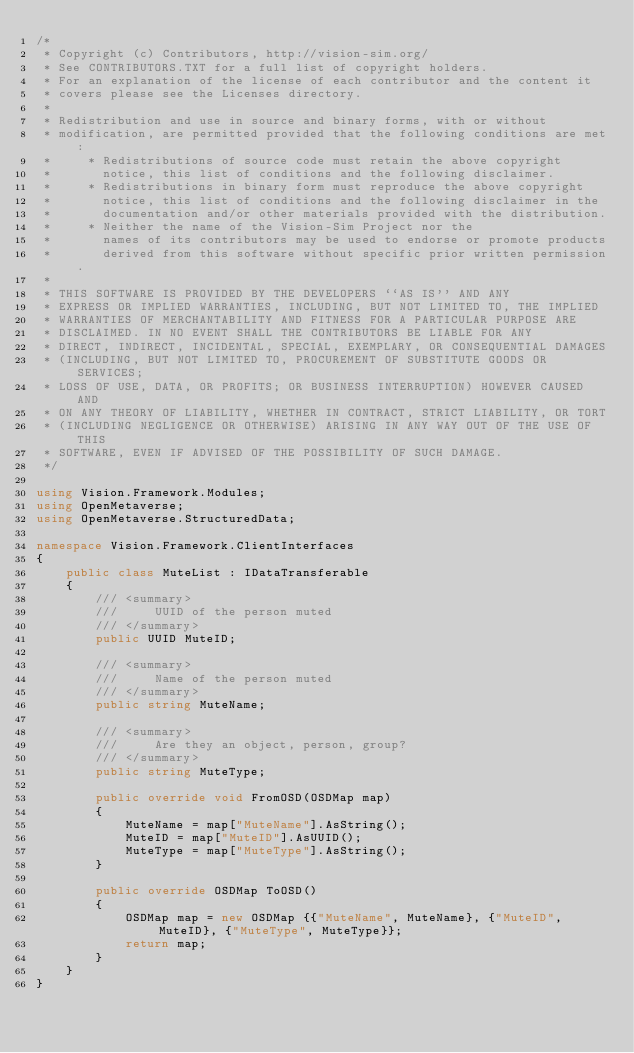Convert code to text. <code><loc_0><loc_0><loc_500><loc_500><_C#_>/*
 * Copyright (c) Contributors, http://vision-sim.org/
 * See CONTRIBUTORS.TXT for a full list of copyright holders.
 * For an explanation of the license of each contributor and the content it 
 * covers please see the Licenses directory.
 *
 * Redistribution and use in source and binary forms, with or without
 * modification, are permitted provided that the following conditions are met:
 *     * Redistributions of source code must retain the above copyright
 *       notice, this list of conditions and the following disclaimer.
 *     * Redistributions in binary form must reproduce the above copyright
 *       notice, this list of conditions and the following disclaimer in the
 *       documentation and/or other materials provided with the distribution.
 *     * Neither the name of the Vision-Sim Project nor the
 *       names of its contributors may be used to endorse or promote products
 *       derived from this software without specific prior written permission.
 *
 * THIS SOFTWARE IS PROVIDED BY THE DEVELOPERS ``AS IS'' AND ANY
 * EXPRESS OR IMPLIED WARRANTIES, INCLUDING, BUT NOT LIMITED TO, THE IMPLIED
 * WARRANTIES OF MERCHANTABILITY AND FITNESS FOR A PARTICULAR PURPOSE ARE
 * DISCLAIMED. IN NO EVENT SHALL THE CONTRIBUTORS BE LIABLE FOR ANY
 * DIRECT, INDIRECT, INCIDENTAL, SPECIAL, EXEMPLARY, OR CONSEQUENTIAL DAMAGES
 * (INCLUDING, BUT NOT LIMITED TO, PROCUREMENT OF SUBSTITUTE GOODS OR SERVICES;
 * LOSS OF USE, DATA, OR PROFITS; OR BUSINESS INTERRUPTION) HOWEVER CAUSED AND
 * ON ANY THEORY OF LIABILITY, WHETHER IN CONTRACT, STRICT LIABILITY, OR TORT
 * (INCLUDING NEGLIGENCE OR OTHERWISE) ARISING IN ANY WAY OUT OF THE USE OF THIS
 * SOFTWARE, EVEN IF ADVISED OF THE POSSIBILITY OF SUCH DAMAGE.
 */

using Vision.Framework.Modules;
using OpenMetaverse;
using OpenMetaverse.StructuredData;

namespace Vision.Framework.ClientInterfaces
{
    public class MuteList : IDataTransferable
    {
        /// <summary>
        ///     UUID of the person muted
        /// </summary>
        public UUID MuteID;

        /// <summary>
        ///     Name of the person muted
        /// </summary>
        public string MuteName;

        /// <summary>
        ///     Are they an object, person, group?
        /// </summary>
        public string MuteType;

        public override void FromOSD(OSDMap map)
        {
            MuteName = map["MuteName"].AsString();
            MuteID = map["MuteID"].AsUUID();
            MuteType = map["MuteType"].AsString();
        }

        public override OSDMap ToOSD()
        {
            OSDMap map = new OSDMap {{"MuteName", MuteName}, {"MuteID", MuteID}, {"MuteType", MuteType}};
            return map;
        }
    }
}</code> 